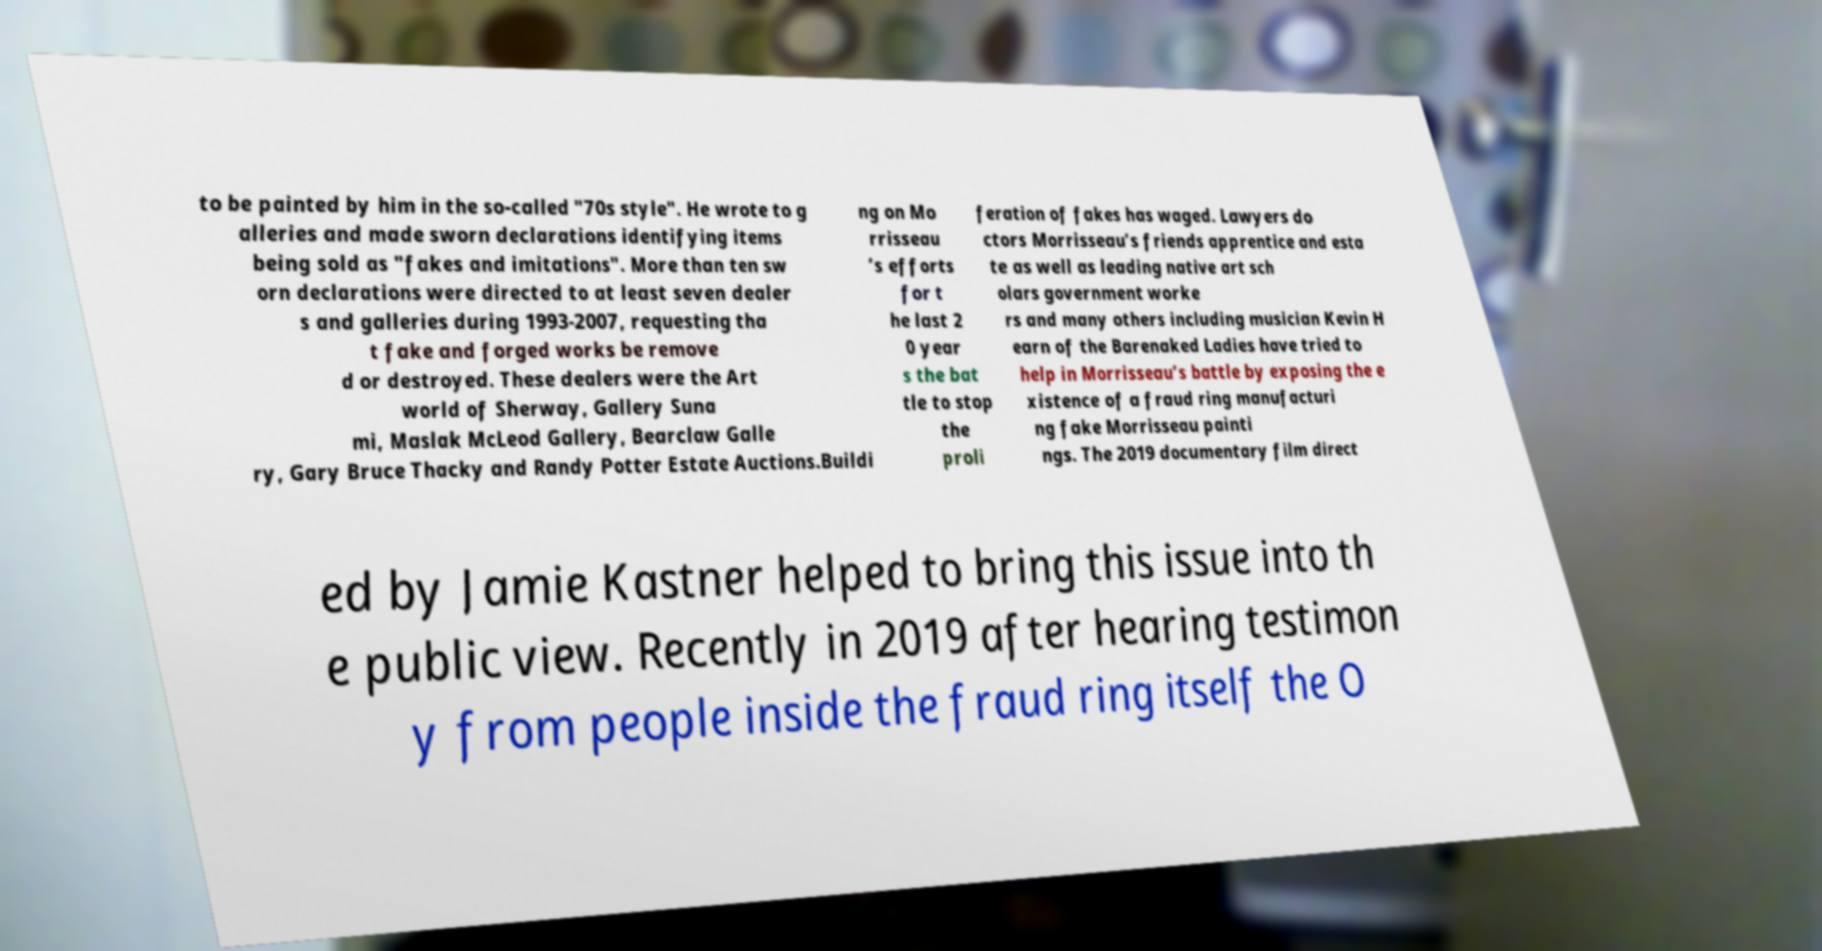Could you extract and type out the text from this image? to be painted by him in the so-called "70s style". He wrote to g alleries and made sworn declarations identifying items being sold as "fakes and imitations". More than ten sw orn declarations were directed to at least seven dealer s and galleries during 1993-2007, requesting tha t fake and forged works be remove d or destroyed. These dealers were the Art world of Sherway, Gallery Suna mi, Maslak McLeod Gallery, Bearclaw Galle ry, Gary Bruce Thacky and Randy Potter Estate Auctions.Buildi ng on Mo rrisseau ’s efforts for t he last 2 0 year s the bat tle to stop the proli feration of fakes has waged. Lawyers do ctors Morrisseau’s friends apprentice and esta te as well as leading native art sch olars government worke rs and many others including musician Kevin H earn of the Barenaked Ladies have tried to help in Morrisseau’s battle by exposing the e xistence of a fraud ring manufacturi ng fake Morrisseau painti ngs. The 2019 documentary film direct ed by Jamie Kastner helped to bring this issue into th e public view. Recently in 2019 after hearing testimon y from people inside the fraud ring itself the O 